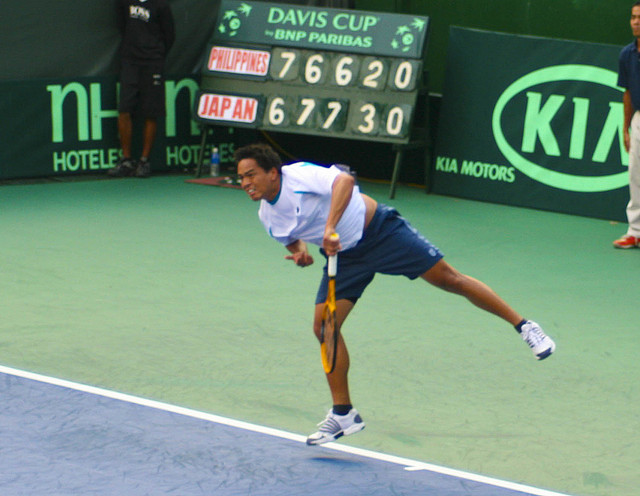Please transcribe the text information in this image. 7 6 6 DAVIS CUP BNP MOTORS KIA 6 7 7 3 0 0 2 PARIBAS PHILIPPINES JAPAN HOT HOTELE 